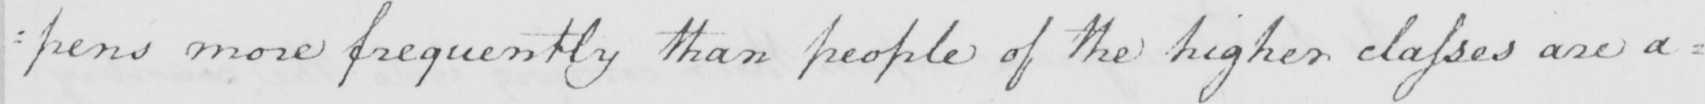Can you read and transcribe this handwriting? : pens more frequently than people of the higher classes are a= 